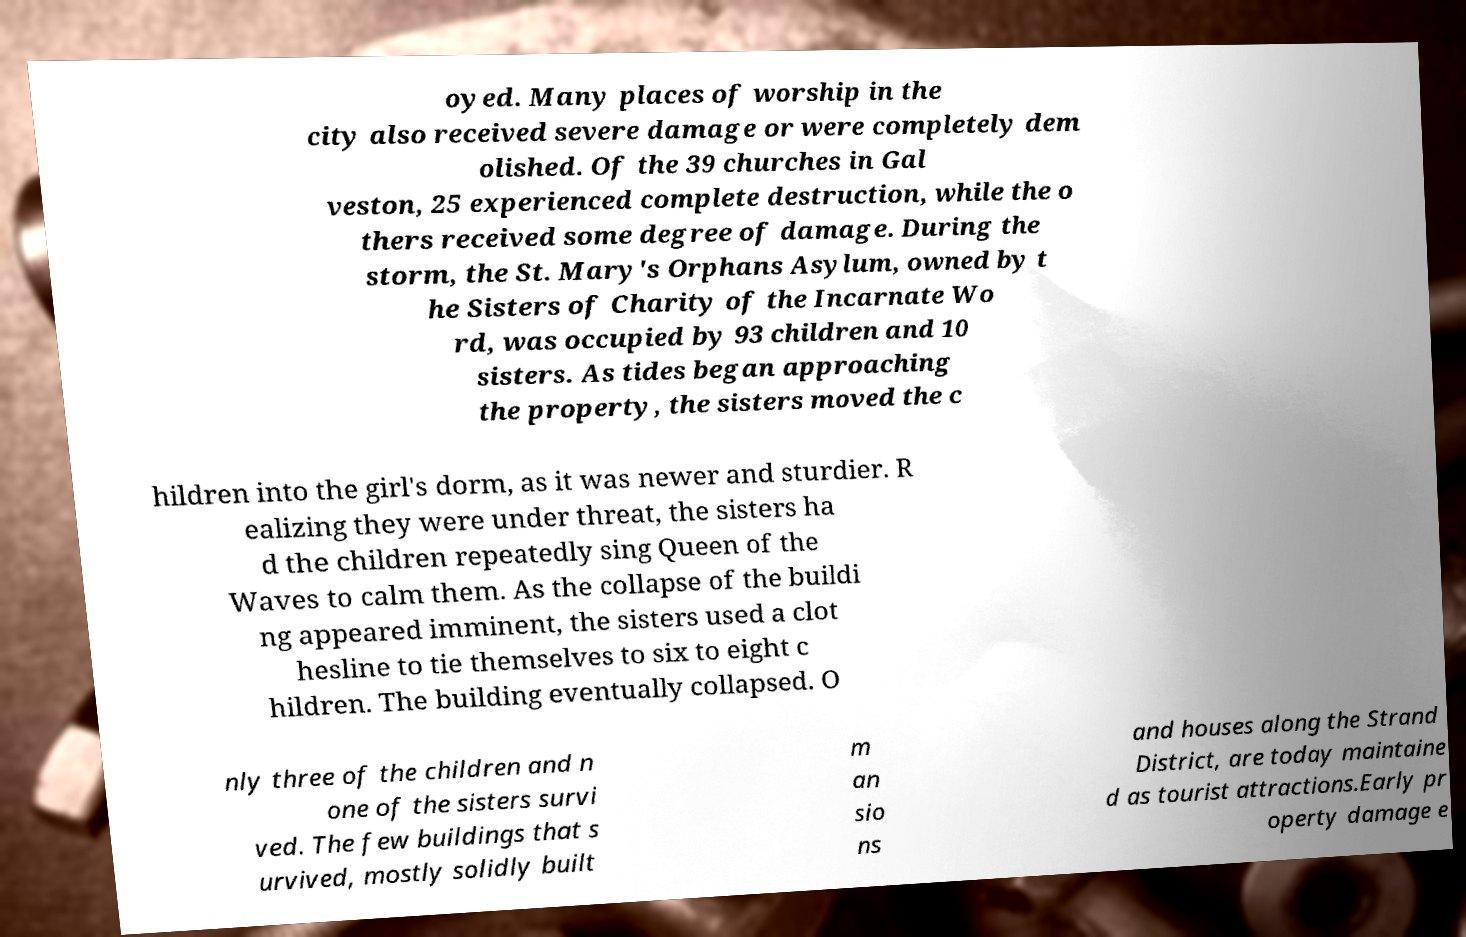For documentation purposes, I need the text within this image transcribed. Could you provide that? oyed. Many places of worship in the city also received severe damage or were completely dem olished. Of the 39 churches in Gal veston, 25 experienced complete destruction, while the o thers received some degree of damage. During the storm, the St. Mary's Orphans Asylum, owned by t he Sisters of Charity of the Incarnate Wo rd, was occupied by 93 children and 10 sisters. As tides began approaching the property, the sisters moved the c hildren into the girl's dorm, as it was newer and sturdier. R ealizing they were under threat, the sisters ha d the children repeatedly sing Queen of the Waves to calm them. As the collapse of the buildi ng appeared imminent, the sisters used a clot hesline to tie themselves to six to eight c hildren. The building eventually collapsed. O nly three of the children and n one of the sisters survi ved. The few buildings that s urvived, mostly solidly built m an sio ns and houses along the Strand District, are today maintaine d as tourist attractions.Early pr operty damage e 